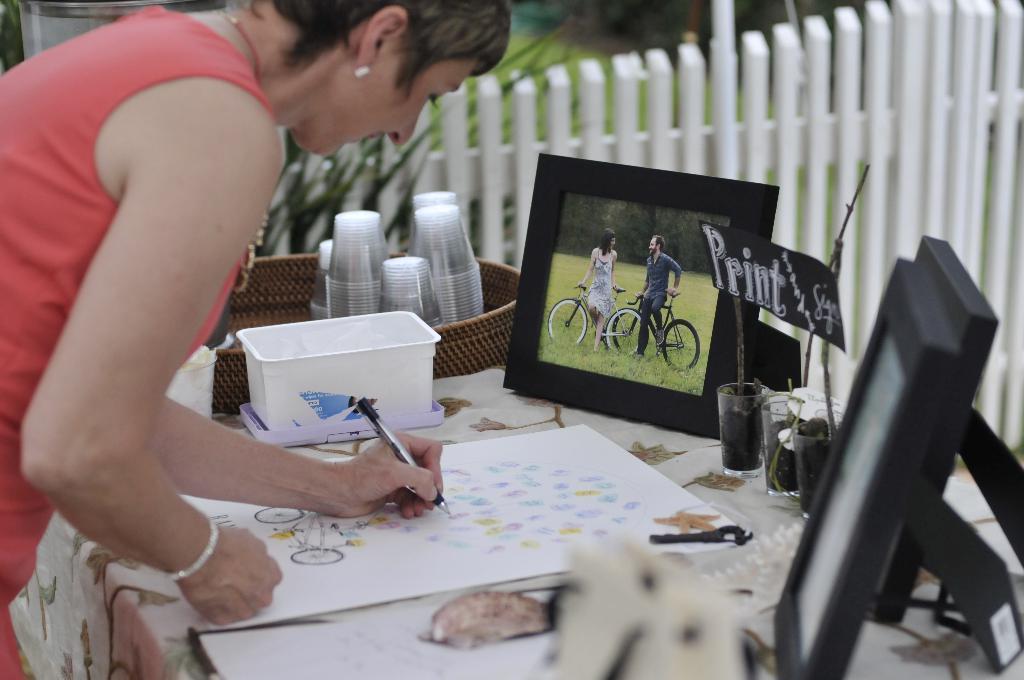Please provide a concise description of this image. In this picture we can see a woman standing and holding a pen in her hand and drawing on a paper. On the table we can see glasses in a tub, box, photo frames. 